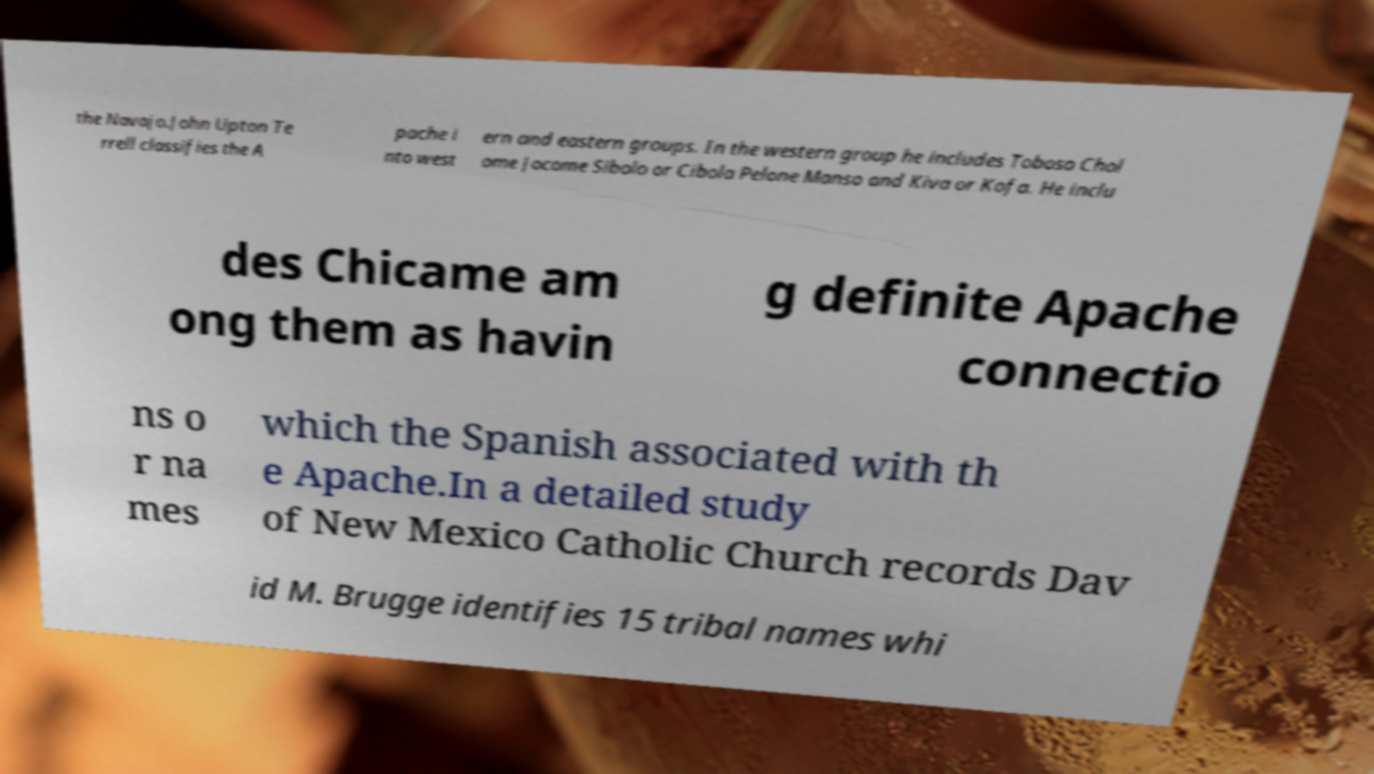Could you assist in decoding the text presented in this image and type it out clearly? the Navajo.John Upton Te rrell classifies the A pache i nto west ern and eastern groups. In the western group he includes Toboso Chol ome Jocome Sibolo or Cibola Pelone Manso and Kiva or Kofa. He inclu des Chicame am ong them as havin g definite Apache connectio ns o r na mes which the Spanish associated with th e Apache.In a detailed study of New Mexico Catholic Church records Dav id M. Brugge identifies 15 tribal names whi 